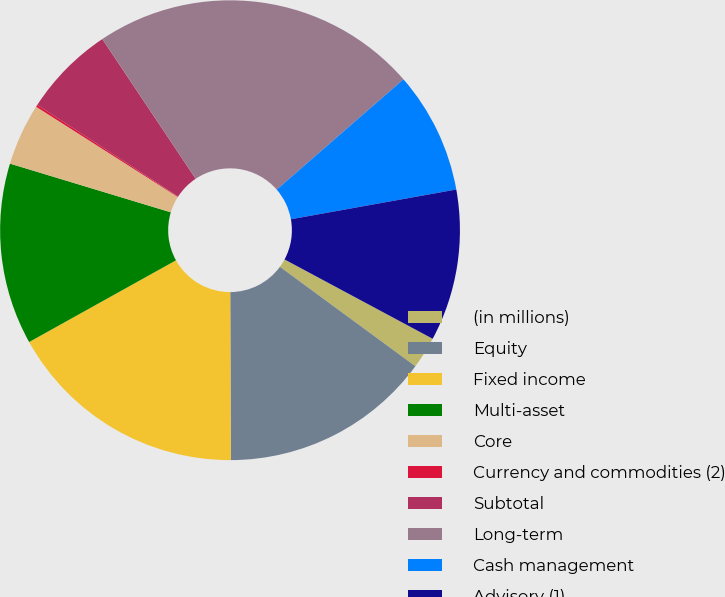Convert chart. <chart><loc_0><loc_0><loc_500><loc_500><pie_chart><fcel>(in millions)<fcel>Equity<fcel>Fixed income<fcel>Multi-asset<fcel>Core<fcel>Currency and commodities (2)<fcel>Subtotal<fcel>Long-term<fcel>Cash management<fcel>Advisory (1)<nl><fcel>2.25%<fcel>14.87%<fcel>16.97%<fcel>12.76%<fcel>4.35%<fcel>0.15%<fcel>6.45%<fcel>22.98%<fcel>8.56%<fcel>10.66%<nl></chart> 